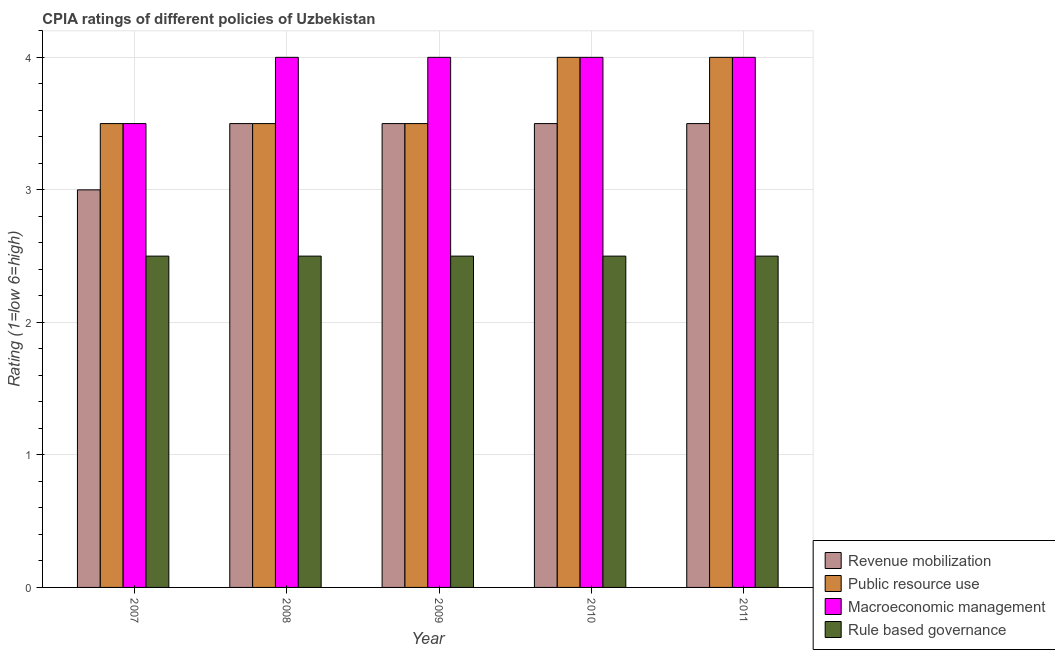How many different coloured bars are there?
Provide a succinct answer. 4. How many groups of bars are there?
Give a very brief answer. 5. How many bars are there on the 1st tick from the right?
Your response must be concise. 4. What is the label of the 2nd group of bars from the left?
Make the answer very short. 2008. In how many cases, is the number of bars for a given year not equal to the number of legend labels?
Your answer should be very brief. 0. Across all years, what is the maximum cpia rating of rule based governance?
Offer a terse response. 2.5. In which year was the cpia rating of macroeconomic management maximum?
Your answer should be very brief. 2008. In which year was the cpia rating of macroeconomic management minimum?
Your answer should be very brief. 2007. What is the difference between the cpia rating of revenue mobilization in 2007 and that in 2008?
Give a very brief answer. -0.5. What is the difference between the cpia rating of rule based governance in 2008 and the cpia rating of revenue mobilization in 2009?
Your answer should be compact. 0. Is the cpia rating of rule based governance in 2008 less than that in 2010?
Your answer should be very brief. No. In how many years, is the cpia rating of revenue mobilization greater than the average cpia rating of revenue mobilization taken over all years?
Make the answer very short. 4. Is the sum of the cpia rating of macroeconomic management in 2007 and 2008 greater than the maximum cpia rating of rule based governance across all years?
Provide a succinct answer. Yes. What does the 1st bar from the left in 2008 represents?
Your answer should be compact. Revenue mobilization. What does the 1st bar from the right in 2009 represents?
Your answer should be very brief. Rule based governance. How many bars are there?
Ensure brevity in your answer.  20. Does the graph contain any zero values?
Ensure brevity in your answer.  No. How many legend labels are there?
Your answer should be very brief. 4. How are the legend labels stacked?
Your answer should be compact. Vertical. What is the title of the graph?
Your response must be concise. CPIA ratings of different policies of Uzbekistan. What is the label or title of the X-axis?
Provide a succinct answer. Year. What is the label or title of the Y-axis?
Your answer should be compact. Rating (1=low 6=high). What is the Rating (1=low 6=high) of Rule based governance in 2007?
Give a very brief answer. 2.5. What is the Rating (1=low 6=high) in Rule based governance in 2008?
Make the answer very short. 2.5. What is the Rating (1=low 6=high) of Revenue mobilization in 2009?
Provide a short and direct response. 3.5. What is the Rating (1=low 6=high) in Revenue mobilization in 2010?
Your response must be concise. 3.5. What is the Rating (1=low 6=high) in Revenue mobilization in 2011?
Provide a short and direct response. 3.5. What is the Rating (1=low 6=high) in Public resource use in 2011?
Give a very brief answer. 4. Across all years, what is the maximum Rating (1=low 6=high) of Revenue mobilization?
Ensure brevity in your answer.  3.5. Across all years, what is the maximum Rating (1=low 6=high) in Public resource use?
Provide a short and direct response. 4. Across all years, what is the maximum Rating (1=low 6=high) in Macroeconomic management?
Ensure brevity in your answer.  4. Across all years, what is the maximum Rating (1=low 6=high) in Rule based governance?
Provide a succinct answer. 2.5. Across all years, what is the minimum Rating (1=low 6=high) of Macroeconomic management?
Offer a very short reply. 3.5. Across all years, what is the minimum Rating (1=low 6=high) of Rule based governance?
Give a very brief answer. 2.5. What is the total Rating (1=low 6=high) in Macroeconomic management in the graph?
Offer a very short reply. 19.5. What is the difference between the Rating (1=low 6=high) in Public resource use in 2007 and that in 2008?
Make the answer very short. 0. What is the difference between the Rating (1=low 6=high) in Public resource use in 2007 and that in 2009?
Offer a terse response. 0. What is the difference between the Rating (1=low 6=high) of Macroeconomic management in 2007 and that in 2009?
Your answer should be compact. -0.5. What is the difference between the Rating (1=low 6=high) in Rule based governance in 2007 and that in 2009?
Your response must be concise. 0. What is the difference between the Rating (1=low 6=high) in Revenue mobilization in 2007 and that in 2010?
Ensure brevity in your answer.  -0.5. What is the difference between the Rating (1=low 6=high) in Public resource use in 2007 and that in 2010?
Give a very brief answer. -0.5. What is the difference between the Rating (1=low 6=high) of Macroeconomic management in 2007 and that in 2010?
Your answer should be compact. -0.5. What is the difference between the Rating (1=low 6=high) in Rule based governance in 2007 and that in 2010?
Provide a succinct answer. 0. What is the difference between the Rating (1=low 6=high) of Public resource use in 2007 and that in 2011?
Provide a short and direct response. -0.5. What is the difference between the Rating (1=low 6=high) in Macroeconomic management in 2007 and that in 2011?
Offer a terse response. -0.5. What is the difference between the Rating (1=low 6=high) in Revenue mobilization in 2008 and that in 2009?
Ensure brevity in your answer.  0. What is the difference between the Rating (1=low 6=high) in Public resource use in 2008 and that in 2009?
Offer a very short reply. 0. What is the difference between the Rating (1=low 6=high) of Macroeconomic management in 2008 and that in 2009?
Offer a terse response. 0. What is the difference between the Rating (1=low 6=high) in Rule based governance in 2008 and that in 2009?
Ensure brevity in your answer.  0. What is the difference between the Rating (1=low 6=high) in Revenue mobilization in 2008 and that in 2010?
Keep it short and to the point. 0. What is the difference between the Rating (1=low 6=high) in Rule based governance in 2008 and that in 2010?
Keep it short and to the point. 0. What is the difference between the Rating (1=low 6=high) of Revenue mobilization in 2008 and that in 2011?
Offer a very short reply. 0. What is the difference between the Rating (1=low 6=high) in Public resource use in 2009 and that in 2010?
Your answer should be compact. -0.5. What is the difference between the Rating (1=low 6=high) in Macroeconomic management in 2009 and that in 2010?
Make the answer very short. 0. What is the difference between the Rating (1=low 6=high) in Revenue mobilization in 2009 and that in 2011?
Provide a succinct answer. 0. What is the difference between the Rating (1=low 6=high) of Public resource use in 2010 and that in 2011?
Give a very brief answer. 0. What is the difference between the Rating (1=low 6=high) of Macroeconomic management in 2010 and that in 2011?
Offer a very short reply. 0. What is the difference between the Rating (1=low 6=high) of Rule based governance in 2010 and that in 2011?
Offer a terse response. 0. What is the difference between the Rating (1=low 6=high) of Revenue mobilization in 2007 and the Rating (1=low 6=high) of Macroeconomic management in 2008?
Provide a succinct answer. -1. What is the difference between the Rating (1=low 6=high) in Revenue mobilization in 2007 and the Rating (1=low 6=high) in Rule based governance in 2008?
Offer a terse response. 0.5. What is the difference between the Rating (1=low 6=high) in Public resource use in 2007 and the Rating (1=low 6=high) in Macroeconomic management in 2008?
Offer a very short reply. -0.5. What is the difference between the Rating (1=low 6=high) in Macroeconomic management in 2007 and the Rating (1=low 6=high) in Rule based governance in 2009?
Provide a short and direct response. 1. What is the difference between the Rating (1=low 6=high) of Revenue mobilization in 2007 and the Rating (1=low 6=high) of Rule based governance in 2010?
Offer a very short reply. 0.5. What is the difference between the Rating (1=low 6=high) in Public resource use in 2007 and the Rating (1=low 6=high) in Rule based governance in 2010?
Provide a succinct answer. 1. What is the difference between the Rating (1=low 6=high) of Macroeconomic management in 2007 and the Rating (1=low 6=high) of Rule based governance in 2010?
Offer a very short reply. 1. What is the difference between the Rating (1=low 6=high) of Revenue mobilization in 2007 and the Rating (1=low 6=high) of Public resource use in 2011?
Provide a short and direct response. -1. What is the difference between the Rating (1=low 6=high) in Revenue mobilization in 2007 and the Rating (1=low 6=high) in Rule based governance in 2011?
Provide a short and direct response. 0.5. What is the difference between the Rating (1=low 6=high) of Revenue mobilization in 2008 and the Rating (1=low 6=high) of Public resource use in 2009?
Provide a short and direct response. 0. What is the difference between the Rating (1=low 6=high) in Revenue mobilization in 2008 and the Rating (1=low 6=high) in Rule based governance in 2009?
Your answer should be very brief. 1. What is the difference between the Rating (1=low 6=high) of Macroeconomic management in 2008 and the Rating (1=low 6=high) of Rule based governance in 2009?
Give a very brief answer. 1.5. What is the difference between the Rating (1=low 6=high) in Revenue mobilization in 2008 and the Rating (1=low 6=high) in Public resource use in 2011?
Offer a terse response. -0.5. What is the difference between the Rating (1=low 6=high) in Public resource use in 2008 and the Rating (1=low 6=high) in Rule based governance in 2011?
Make the answer very short. 1. What is the difference between the Rating (1=low 6=high) of Revenue mobilization in 2009 and the Rating (1=low 6=high) of Public resource use in 2010?
Your answer should be very brief. -0.5. What is the difference between the Rating (1=low 6=high) in Revenue mobilization in 2009 and the Rating (1=low 6=high) in Rule based governance in 2010?
Ensure brevity in your answer.  1. What is the difference between the Rating (1=low 6=high) in Public resource use in 2009 and the Rating (1=low 6=high) in Macroeconomic management in 2010?
Make the answer very short. -0.5. What is the difference between the Rating (1=low 6=high) of Macroeconomic management in 2009 and the Rating (1=low 6=high) of Rule based governance in 2010?
Your answer should be compact. 1.5. What is the difference between the Rating (1=low 6=high) of Revenue mobilization in 2009 and the Rating (1=low 6=high) of Public resource use in 2011?
Offer a very short reply. -0.5. What is the difference between the Rating (1=low 6=high) of Revenue mobilization in 2009 and the Rating (1=low 6=high) of Macroeconomic management in 2011?
Your response must be concise. -0.5. What is the difference between the Rating (1=low 6=high) of Revenue mobilization in 2009 and the Rating (1=low 6=high) of Rule based governance in 2011?
Give a very brief answer. 1. What is the difference between the Rating (1=low 6=high) in Macroeconomic management in 2009 and the Rating (1=low 6=high) in Rule based governance in 2011?
Offer a terse response. 1.5. What is the difference between the Rating (1=low 6=high) of Revenue mobilization in 2010 and the Rating (1=low 6=high) of Public resource use in 2011?
Make the answer very short. -0.5. What is the difference between the Rating (1=low 6=high) in Public resource use in 2010 and the Rating (1=low 6=high) in Macroeconomic management in 2011?
Give a very brief answer. 0. What is the difference between the Rating (1=low 6=high) in Public resource use in 2010 and the Rating (1=low 6=high) in Rule based governance in 2011?
Give a very brief answer. 1.5. What is the difference between the Rating (1=low 6=high) of Macroeconomic management in 2010 and the Rating (1=low 6=high) of Rule based governance in 2011?
Offer a terse response. 1.5. What is the average Rating (1=low 6=high) of Public resource use per year?
Your answer should be compact. 3.7. What is the average Rating (1=low 6=high) of Macroeconomic management per year?
Offer a very short reply. 3.9. What is the average Rating (1=low 6=high) of Rule based governance per year?
Ensure brevity in your answer.  2.5. In the year 2007, what is the difference between the Rating (1=low 6=high) in Revenue mobilization and Rating (1=low 6=high) in Macroeconomic management?
Keep it short and to the point. -0.5. In the year 2007, what is the difference between the Rating (1=low 6=high) in Public resource use and Rating (1=low 6=high) in Macroeconomic management?
Your response must be concise. 0. In the year 2007, what is the difference between the Rating (1=low 6=high) in Public resource use and Rating (1=low 6=high) in Rule based governance?
Your answer should be very brief. 1. In the year 2007, what is the difference between the Rating (1=low 6=high) in Macroeconomic management and Rating (1=low 6=high) in Rule based governance?
Your answer should be compact. 1. In the year 2008, what is the difference between the Rating (1=low 6=high) in Revenue mobilization and Rating (1=low 6=high) in Public resource use?
Give a very brief answer. 0. In the year 2008, what is the difference between the Rating (1=low 6=high) of Public resource use and Rating (1=low 6=high) of Macroeconomic management?
Your answer should be compact. -0.5. In the year 2008, what is the difference between the Rating (1=low 6=high) in Public resource use and Rating (1=low 6=high) in Rule based governance?
Give a very brief answer. 1. In the year 2009, what is the difference between the Rating (1=low 6=high) in Revenue mobilization and Rating (1=low 6=high) in Macroeconomic management?
Provide a short and direct response. -0.5. In the year 2009, what is the difference between the Rating (1=low 6=high) of Public resource use and Rating (1=low 6=high) of Macroeconomic management?
Give a very brief answer. -0.5. In the year 2009, what is the difference between the Rating (1=low 6=high) of Macroeconomic management and Rating (1=low 6=high) of Rule based governance?
Give a very brief answer. 1.5. In the year 2010, what is the difference between the Rating (1=low 6=high) in Revenue mobilization and Rating (1=low 6=high) in Public resource use?
Ensure brevity in your answer.  -0.5. In the year 2010, what is the difference between the Rating (1=low 6=high) in Revenue mobilization and Rating (1=low 6=high) in Macroeconomic management?
Offer a terse response. -0.5. In the year 2010, what is the difference between the Rating (1=low 6=high) in Revenue mobilization and Rating (1=low 6=high) in Rule based governance?
Give a very brief answer. 1. In the year 2010, what is the difference between the Rating (1=low 6=high) in Public resource use and Rating (1=low 6=high) in Macroeconomic management?
Your answer should be compact. 0. In the year 2010, what is the difference between the Rating (1=low 6=high) of Public resource use and Rating (1=low 6=high) of Rule based governance?
Provide a short and direct response. 1.5. In the year 2010, what is the difference between the Rating (1=low 6=high) of Macroeconomic management and Rating (1=low 6=high) of Rule based governance?
Your answer should be very brief. 1.5. In the year 2011, what is the difference between the Rating (1=low 6=high) in Revenue mobilization and Rating (1=low 6=high) in Rule based governance?
Provide a short and direct response. 1. In the year 2011, what is the difference between the Rating (1=low 6=high) in Public resource use and Rating (1=low 6=high) in Rule based governance?
Offer a very short reply. 1.5. What is the ratio of the Rating (1=low 6=high) of Revenue mobilization in 2007 to that in 2008?
Provide a short and direct response. 0.86. What is the ratio of the Rating (1=low 6=high) in Public resource use in 2007 to that in 2008?
Keep it short and to the point. 1. What is the ratio of the Rating (1=low 6=high) in Revenue mobilization in 2007 to that in 2009?
Ensure brevity in your answer.  0.86. What is the ratio of the Rating (1=low 6=high) in Public resource use in 2007 to that in 2009?
Your answer should be compact. 1. What is the ratio of the Rating (1=low 6=high) in Macroeconomic management in 2007 to that in 2009?
Make the answer very short. 0.88. What is the ratio of the Rating (1=low 6=high) of Rule based governance in 2007 to that in 2009?
Provide a short and direct response. 1. What is the ratio of the Rating (1=low 6=high) of Revenue mobilization in 2007 to that in 2010?
Your answer should be very brief. 0.86. What is the ratio of the Rating (1=low 6=high) in Public resource use in 2007 to that in 2010?
Give a very brief answer. 0.88. What is the ratio of the Rating (1=low 6=high) in Macroeconomic management in 2007 to that in 2010?
Offer a very short reply. 0.88. What is the ratio of the Rating (1=low 6=high) of Rule based governance in 2007 to that in 2010?
Provide a succinct answer. 1. What is the ratio of the Rating (1=low 6=high) of Revenue mobilization in 2007 to that in 2011?
Provide a succinct answer. 0.86. What is the ratio of the Rating (1=low 6=high) of Revenue mobilization in 2008 to that in 2009?
Give a very brief answer. 1. What is the ratio of the Rating (1=low 6=high) of Macroeconomic management in 2008 to that in 2009?
Your response must be concise. 1. What is the ratio of the Rating (1=low 6=high) of Revenue mobilization in 2008 to that in 2010?
Offer a terse response. 1. What is the ratio of the Rating (1=low 6=high) of Public resource use in 2008 to that in 2010?
Your answer should be compact. 0.88. What is the ratio of the Rating (1=low 6=high) of Rule based governance in 2008 to that in 2010?
Offer a very short reply. 1. What is the ratio of the Rating (1=low 6=high) of Revenue mobilization in 2008 to that in 2011?
Provide a short and direct response. 1. What is the ratio of the Rating (1=low 6=high) in Rule based governance in 2008 to that in 2011?
Offer a terse response. 1. What is the ratio of the Rating (1=low 6=high) of Public resource use in 2009 to that in 2010?
Keep it short and to the point. 0.88. What is the ratio of the Rating (1=low 6=high) in Rule based governance in 2009 to that in 2010?
Ensure brevity in your answer.  1. What is the ratio of the Rating (1=low 6=high) in Macroeconomic management in 2009 to that in 2011?
Your answer should be very brief. 1. What is the ratio of the Rating (1=low 6=high) of Revenue mobilization in 2010 to that in 2011?
Keep it short and to the point. 1. What is the ratio of the Rating (1=low 6=high) of Macroeconomic management in 2010 to that in 2011?
Keep it short and to the point. 1. What is the difference between the highest and the second highest Rating (1=low 6=high) of Macroeconomic management?
Offer a terse response. 0. What is the difference between the highest and the lowest Rating (1=low 6=high) of Macroeconomic management?
Make the answer very short. 0.5. What is the difference between the highest and the lowest Rating (1=low 6=high) of Rule based governance?
Your response must be concise. 0. 